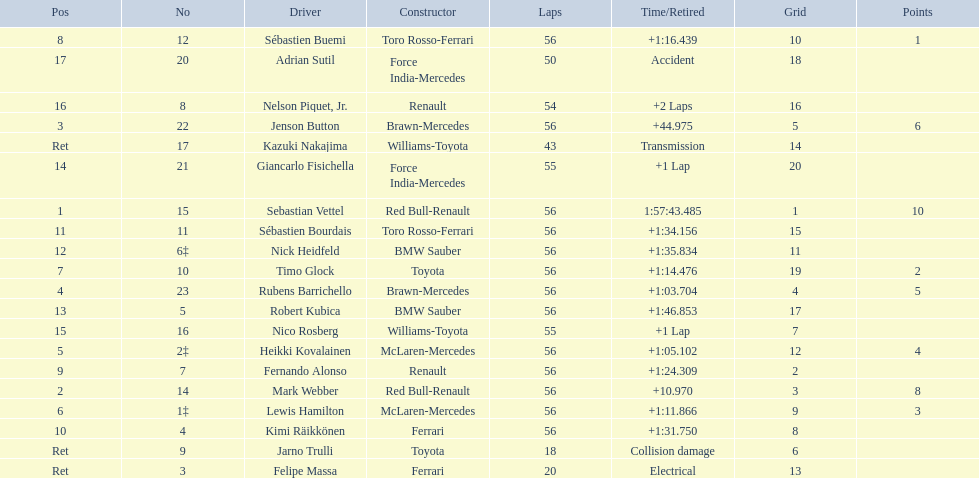Why did the  toyota retire Collision damage. Write the full table. {'header': ['Pos', 'No', 'Driver', 'Constructor', 'Laps', 'Time/Retired', 'Grid', 'Points'], 'rows': [['8', '12', 'Sébastien Buemi', 'Toro Rosso-Ferrari', '56', '+1:16.439', '10', '1'], ['17', '20', 'Adrian Sutil', 'Force India-Mercedes', '50', 'Accident', '18', ''], ['16', '8', 'Nelson Piquet, Jr.', 'Renault', '54', '+2 Laps', '16', ''], ['3', '22', 'Jenson Button', 'Brawn-Mercedes', '56', '+44.975', '5', '6'], ['Ret', '17', 'Kazuki Nakajima', 'Williams-Toyota', '43', 'Transmission', '14', ''], ['14', '21', 'Giancarlo Fisichella', 'Force India-Mercedes', '55', '+1 Lap', '20', ''], ['1', '15', 'Sebastian Vettel', 'Red Bull-Renault', '56', '1:57:43.485', '1', '10'], ['11', '11', 'Sébastien Bourdais', 'Toro Rosso-Ferrari', '56', '+1:34.156', '15', ''], ['12', '6‡', 'Nick Heidfeld', 'BMW Sauber', '56', '+1:35.834', '11', ''], ['7', '10', 'Timo Glock', 'Toyota', '56', '+1:14.476', '19', '2'], ['4', '23', 'Rubens Barrichello', 'Brawn-Mercedes', '56', '+1:03.704', '4', '5'], ['13', '5', 'Robert Kubica', 'BMW Sauber', '56', '+1:46.853', '17', ''], ['15', '16', 'Nico Rosberg', 'Williams-Toyota', '55', '+1 Lap', '7', ''], ['5', '2‡', 'Heikki Kovalainen', 'McLaren-Mercedes', '56', '+1:05.102', '12', '4'], ['9', '7', 'Fernando Alonso', 'Renault', '56', '+1:24.309', '2', ''], ['2', '14', 'Mark Webber', 'Red Bull-Renault', '56', '+10.970', '3', '8'], ['6', '1‡', 'Lewis Hamilton', 'McLaren-Mercedes', '56', '+1:11.866', '9', '3'], ['10', '4', 'Kimi Räikkönen', 'Ferrari', '56', '+1:31.750', '8', ''], ['Ret', '9', 'Jarno Trulli', 'Toyota', '18', 'Collision damage', '6', ''], ['Ret', '3', 'Felipe Massa', 'Ferrari', '20', 'Electrical', '13', '']]} What was the drivers name? Jarno Trulli. 